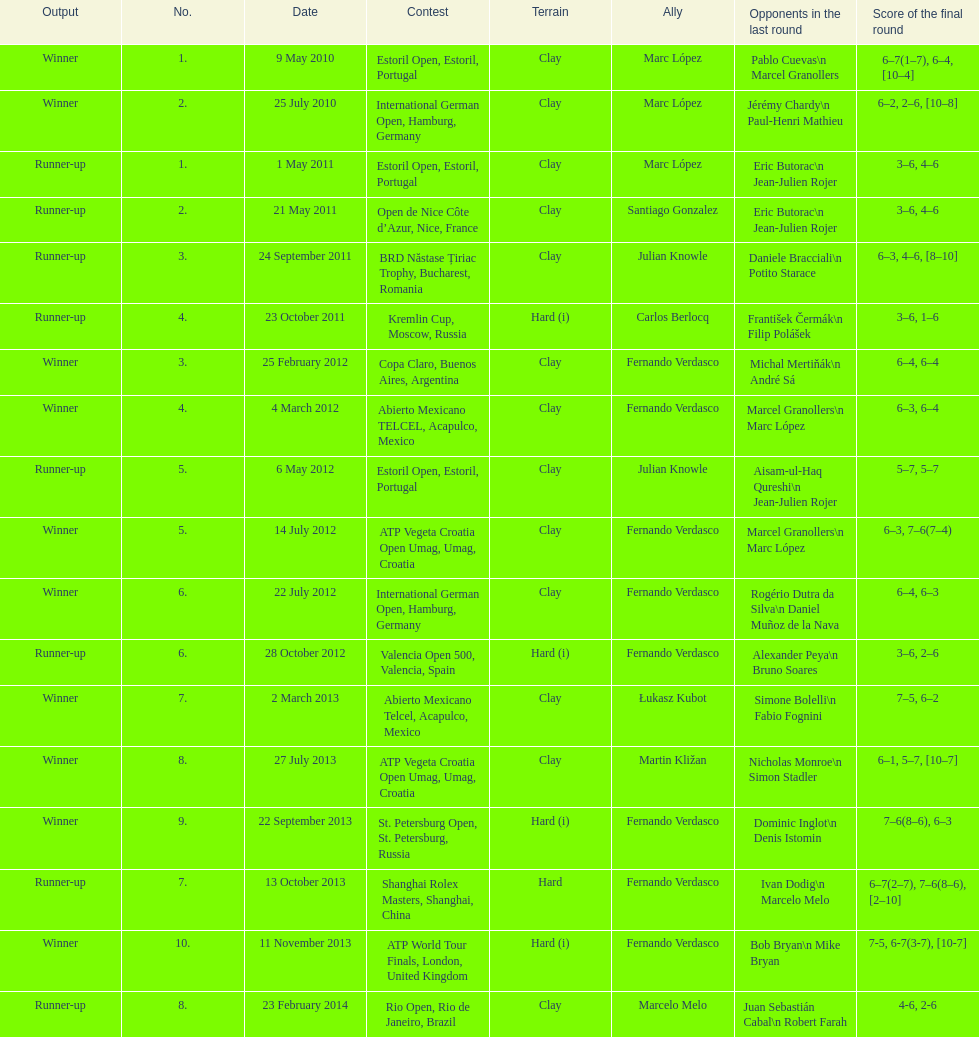Who was this player's next partner after playing with marc lopez in may 2011? Santiago Gonzalez. 